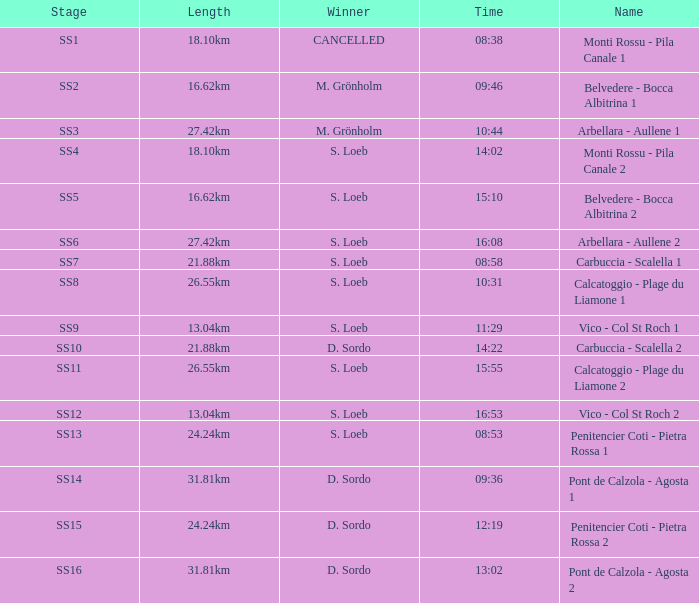What is the Name of the stage with a Length of 16.62km and Time of 15:10? Belvedere - Bocca Albitrina 2. 